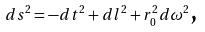Convert formula to latex. <formula><loc_0><loc_0><loc_500><loc_500>d s ^ { 2 } = - d t ^ { 2 } + d l ^ { 2 } + r _ { 0 } ^ { 2 } d \omega ^ { 2 } \text {,}</formula> 